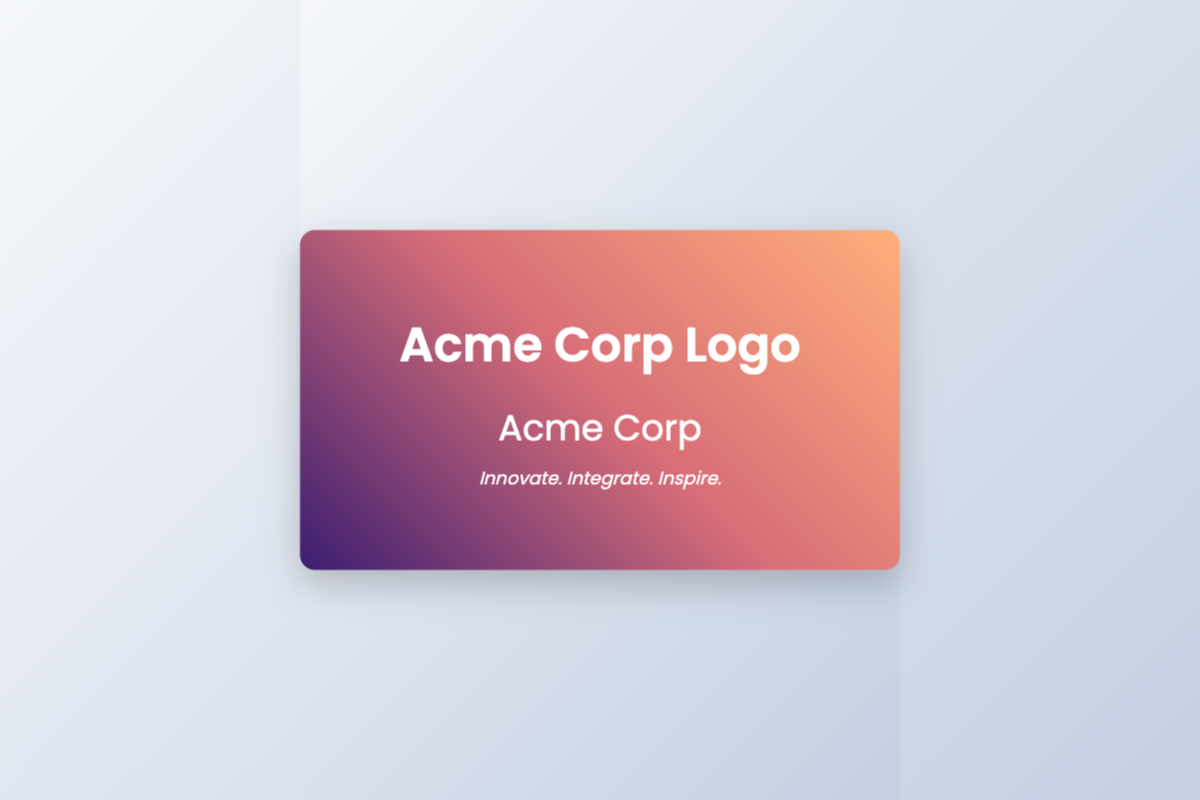What is the company name? The company name can be found prominently on the front side of the card.
Answer: Acme Corp What is the tagline? The tagline is located underneath the company name on the front side of the card.
Answer: Innovate. Integrate. Inspire How many key services are listed? The back side of the card contains a grid of services that can be counted.
Answer: Four What is the mission statement? The mission statement is a comprehensive sentence provided on the back side of the card.
Answer: To deliver innovative technology solutions that empower businesses to achieve their highest potential through seamless integration and inspired designs What service relates to protecting data? One of the services listed on the back side of the card specifically mentions cybersecurity.
Answer: Cybersecurity What service involves software solutions? By reviewing the services provided, one can identify which one focuses on software development.
Answer: Software Development What is the service description for Data Analytics? The description for Data Analytics can be found under the corresponding service on the back side.
Answer: Advanced analytics services to drive data-driven business decisions What number is associated with the consulting service? The consulting service is found on the back side of the card and its related information can be directly retrieved.
Answer: Expert guidance on strategic technology implementation and optimization Which side of the card features the logo? The logo is prominently displayed on the front side of the card.
Answer: Front side 